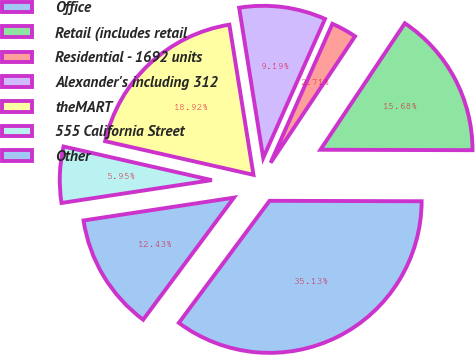Convert chart to OTSL. <chart><loc_0><loc_0><loc_500><loc_500><pie_chart><fcel>Office<fcel>Retail (includes retail<fcel>Residential - 1692 units<fcel>Alexander's including 312<fcel>theMART<fcel>555 California Street<fcel>Other<nl><fcel>35.13%<fcel>15.68%<fcel>2.71%<fcel>9.19%<fcel>18.92%<fcel>5.95%<fcel>12.43%<nl></chart> 